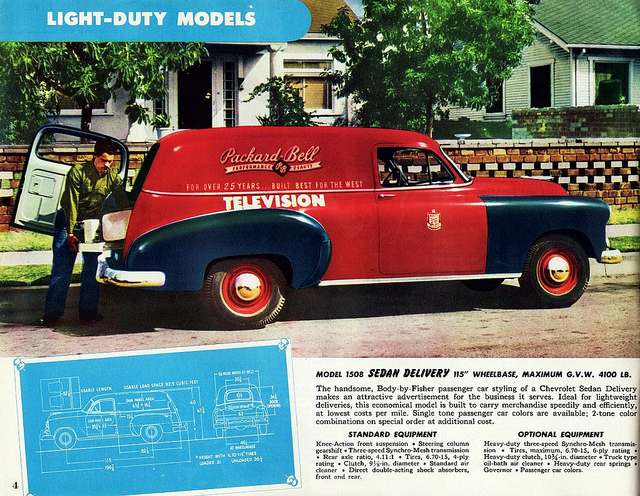Identify the text displayed in this image. LIGHT- -DUTY MODELS TELEVISION -Bell 9 1/8 Passenger Governor oil-bath cleaner Heavy-duty springs 101/1 type track 6--ply maximum Time roting Synchro-Meach three-speed Heavy-duty sunday Ming front and rear aboorbers shock double-acting Direct 4-ply 10-15 ratio Synchro- Transmission column Steering EQUIPMENT STANDARD EQUIPMENT OPTIONAL colors invaliable 2-tone color efficiently and specdily merchandise Lightweight for Ideal serves Delivery cHEVROLET passenger come carry to built is cost additional at Single model economical business the styling car passenger Fisher by Body advertisement attractive order special on costs combinations lowest this deliveries makes handsome, The LB 4100 G.V.W MAXIMUM WHEELBASE, DELIVERY SEDAN 1508 MODEL FOR OVER 25 YEARS WEST THE FOR BEST Packard 